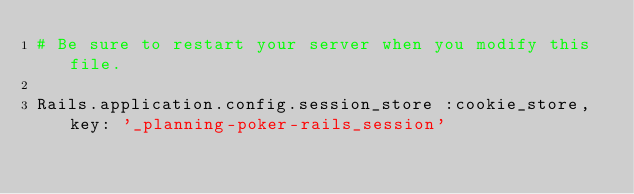Convert code to text. <code><loc_0><loc_0><loc_500><loc_500><_Ruby_># Be sure to restart your server when you modify this file.

Rails.application.config.session_store :cookie_store, key: '_planning-poker-rails_session'</code> 